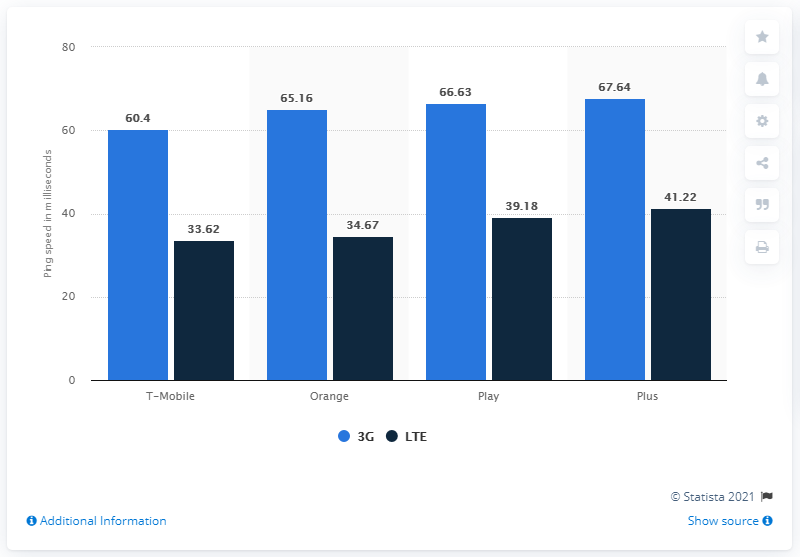Outline some significant characteristics in this image. The average ping speed of LTE is approximately 37.17 megabits per second. The lowest value in the blue bar is 60.4. In 2020, Orange was the leader in both downloading and uploading data in Poland. T-Mobile achieved the lowest ping among other mobile networks in both LTE and 3G networks. 